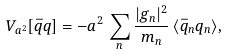<formula> <loc_0><loc_0><loc_500><loc_500>V _ { a ^ { 2 } } [ \bar { q } q ] = - a ^ { 2 } \, \sum _ { n } \frac { | g _ { n } | ^ { 2 } } { m _ { n } } \, \langle \bar { q } _ { n } q _ { n } \rangle ,</formula> 